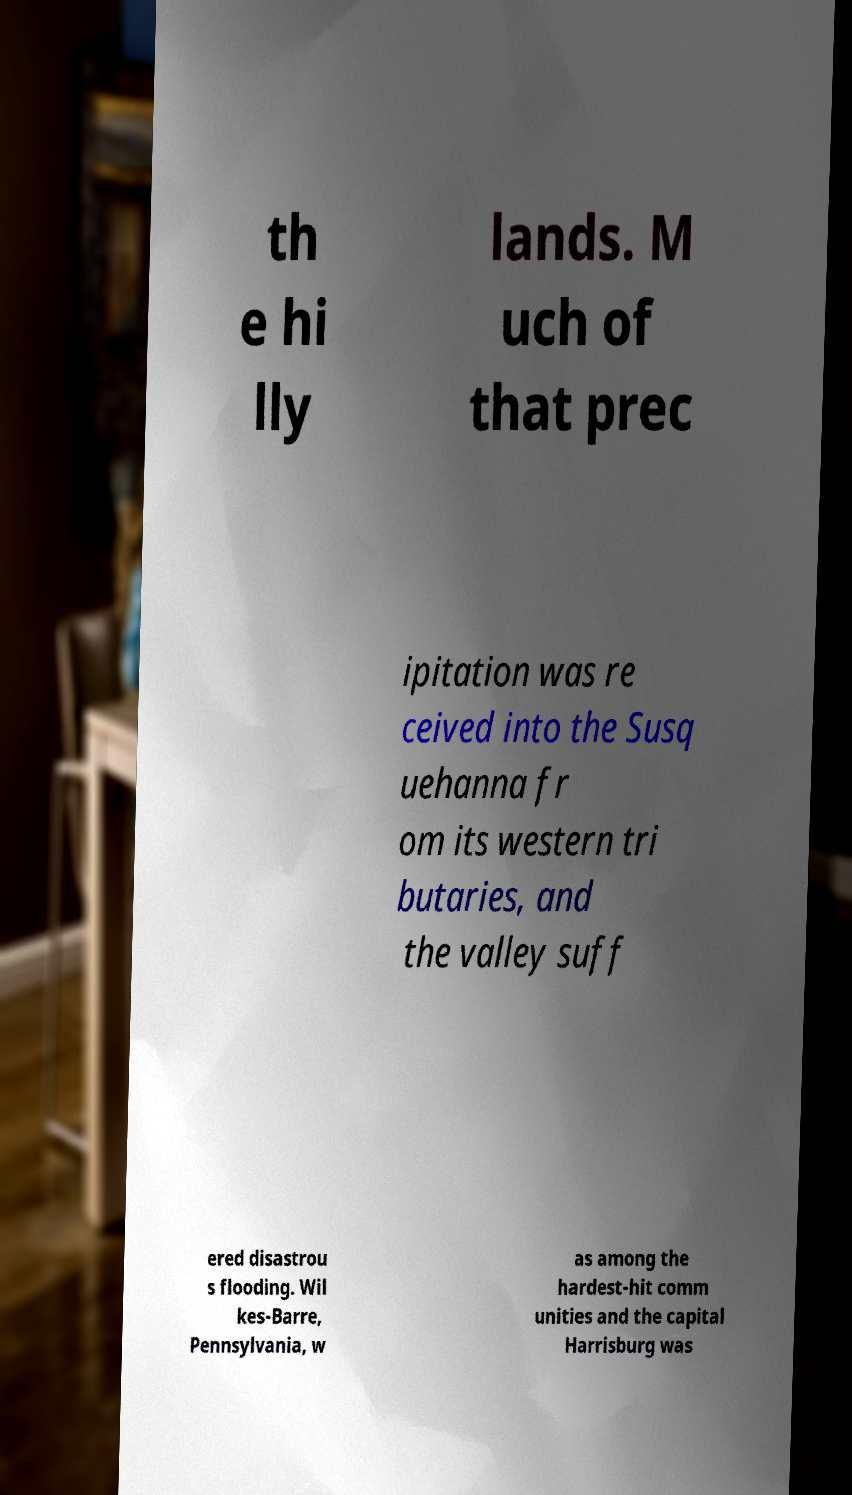For documentation purposes, I need the text within this image transcribed. Could you provide that? th e hi lly lands. M uch of that prec ipitation was re ceived into the Susq uehanna fr om its western tri butaries, and the valley suff ered disastrou s flooding. Wil kes-Barre, Pennsylvania, w as among the hardest-hit comm unities and the capital Harrisburg was 